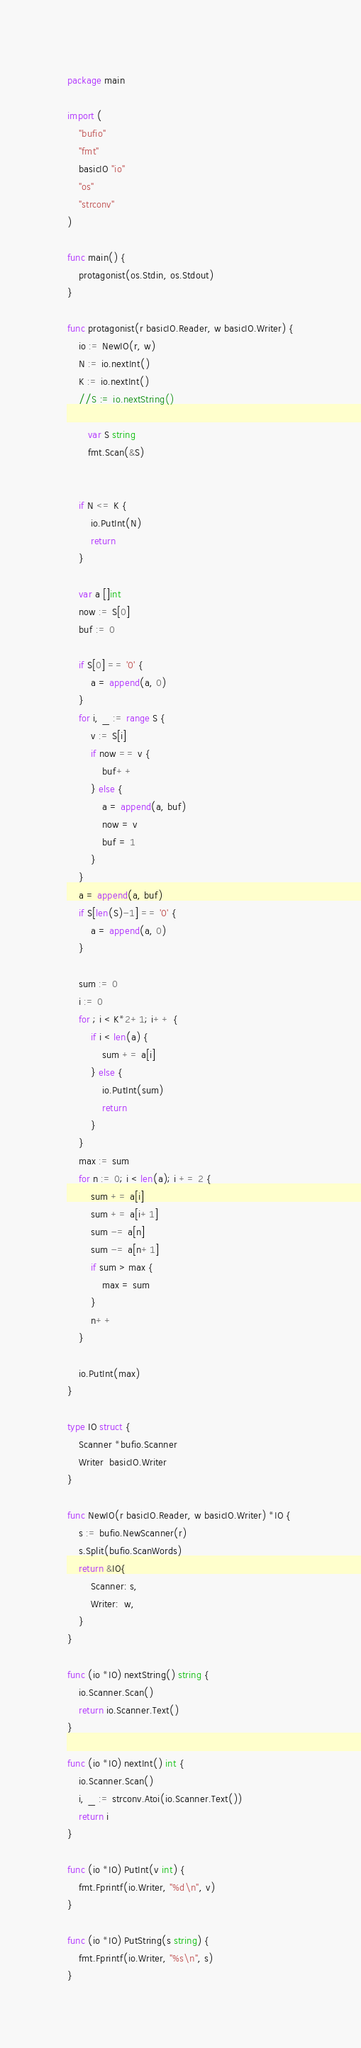<code> <loc_0><loc_0><loc_500><loc_500><_Go_>package main

import (
	"bufio"
	"fmt"
	basicIO "io"
	"os"
	"strconv"
)

func main() {
	protagonist(os.Stdin, os.Stdout)
}

func protagonist(r basicIO.Reader, w basicIO.Writer) {
	io := NewIO(r, w)
	N := io.nextInt()
	K := io.nextInt()
	//S := io.nextString()
	
	   var S string
	   fmt.Scan(&S)
	

	if N <= K {
		io.PutInt(N)
		return
	}

	var a []int
	now := S[0]
	buf := 0

	if S[0] == '0' {
		a = append(a, 0)
	}
	for i, _ := range S {
		v := S[i]
		if now == v {
			buf++
		} else {
			a = append(a, buf)
			now = v
			buf = 1
		}
	}
	a = append(a, buf)
	if S[len(S)-1] == '0' {
		a = append(a, 0)
	}

	sum := 0
	i := 0
	for ; i < K*2+1; i++ {
		if i < len(a) {
			sum += a[i]
		} else {
			io.PutInt(sum)
			return
		}
	}
	max := sum
	for n := 0; i < len(a); i += 2 {
		sum += a[i]
		sum += a[i+1]
		sum -= a[n]
		sum -= a[n+1]
		if sum > max {
			max = sum
		}
		n++
	}

	io.PutInt(max)
}

type IO struct {
	Scanner *bufio.Scanner
	Writer  basicIO.Writer
}

func NewIO(r basicIO.Reader, w basicIO.Writer) *IO {
	s := bufio.NewScanner(r)
	s.Split(bufio.ScanWords)
	return &IO{
		Scanner: s,
		Writer:  w,
	}
}

func (io *IO) nextString() string {
	io.Scanner.Scan()
	return io.Scanner.Text()
}

func (io *IO) nextInt() int {
	io.Scanner.Scan()
	i, _ := strconv.Atoi(io.Scanner.Text())
	return i
}

func (io *IO) PutInt(v int) {
	fmt.Fprintf(io.Writer, "%d\n", v)
}

func (io *IO) PutString(s string) {
	fmt.Fprintf(io.Writer, "%s\n", s)
}
</code> 